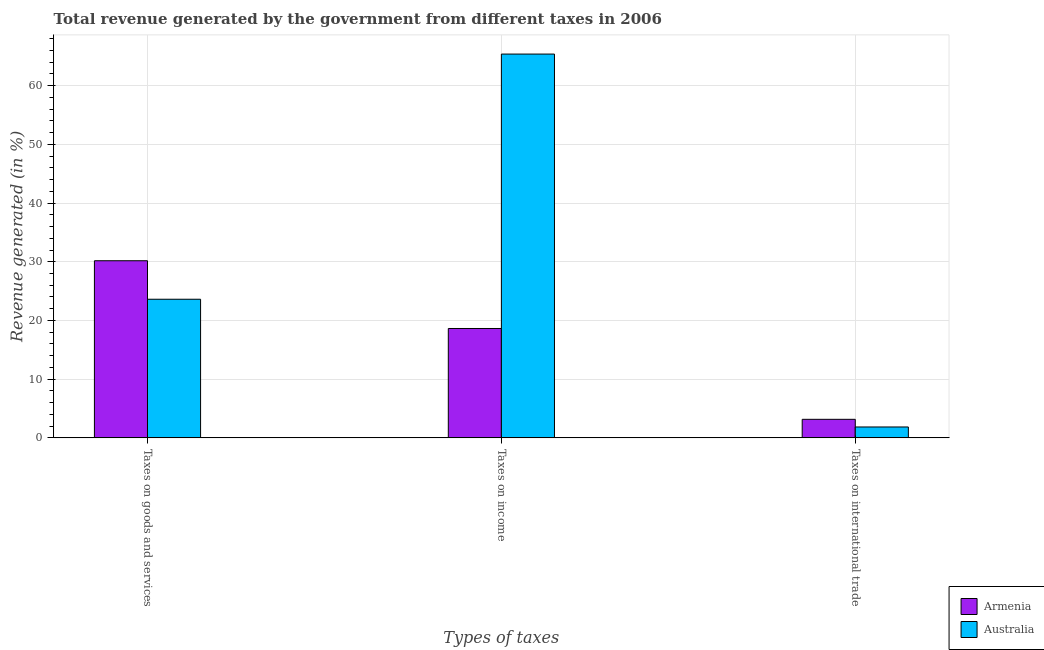How many different coloured bars are there?
Your response must be concise. 2. How many groups of bars are there?
Ensure brevity in your answer.  3. Are the number of bars per tick equal to the number of legend labels?
Ensure brevity in your answer.  Yes. Are the number of bars on each tick of the X-axis equal?
Your answer should be very brief. Yes. How many bars are there on the 2nd tick from the left?
Your response must be concise. 2. What is the label of the 3rd group of bars from the left?
Offer a very short reply. Taxes on international trade. What is the percentage of revenue generated by tax on international trade in Armenia?
Keep it short and to the point. 3.16. Across all countries, what is the maximum percentage of revenue generated by tax on international trade?
Give a very brief answer. 3.16. Across all countries, what is the minimum percentage of revenue generated by tax on international trade?
Offer a terse response. 1.86. In which country was the percentage of revenue generated by tax on international trade maximum?
Your answer should be compact. Armenia. In which country was the percentage of revenue generated by taxes on income minimum?
Your answer should be very brief. Armenia. What is the total percentage of revenue generated by taxes on income in the graph?
Give a very brief answer. 84.01. What is the difference between the percentage of revenue generated by taxes on income in Armenia and that in Australia?
Keep it short and to the point. -46.75. What is the difference between the percentage of revenue generated by tax on international trade in Australia and the percentage of revenue generated by taxes on goods and services in Armenia?
Your response must be concise. -28.31. What is the average percentage of revenue generated by taxes on income per country?
Your response must be concise. 42. What is the difference between the percentage of revenue generated by taxes on goods and services and percentage of revenue generated by tax on international trade in Armenia?
Offer a very short reply. 27.01. In how many countries, is the percentage of revenue generated by taxes on goods and services greater than 66 %?
Make the answer very short. 0. What is the ratio of the percentage of revenue generated by tax on international trade in Armenia to that in Australia?
Ensure brevity in your answer.  1.7. Is the percentage of revenue generated by taxes on income in Armenia less than that in Australia?
Ensure brevity in your answer.  Yes. Is the difference between the percentage of revenue generated by taxes on income in Armenia and Australia greater than the difference between the percentage of revenue generated by taxes on goods and services in Armenia and Australia?
Offer a very short reply. No. What is the difference between the highest and the second highest percentage of revenue generated by taxes on income?
Keep it short and to the point. 46.75. What is the difference between the highest and the lowest percentage of revenue generated by taxes on goods and services?
Your answer should be very brief. 6.56. In how many countries, is the percentage of revenue generated by tax on international trade greater than the average percentage of revenue generated by tax on international trade taken over all countries?
Your answer should be compact. 1. Is the sum of the percentage of revenue generated by taxes on income in Armenia and Australia greater than the maximum percentage of revenue generated by taxes on goods and services across all countries?
Keep it short and to the point. Yes. What does the 1st bar from the left in Taxes on income represents?
Provide a succinct answer. Armenia. What does the 1st bar from the right in Taxes on income represents?
Ensure brevity in your answer.  Australia. Is it the case that in every country, the sum of the percentage of revenue generated by taxes on goods and services and percentage of revenue generated by taxes on income is greater than the percentage of revenue generated by tax on international trade?
Your answer should be very brief. Yes. Are all the bars in the graph horizontal?
Give a very brief answer. No. Does the graph contain any zero values?
Offer a very short reply. No. What is the title of the graph?
Keep it short and to the point. Total revenue generated by the government from different taxes in 2006. Does "Northern Mariana Islands" appear as one of the legend labels in the graph?
Provide a succinct answer. No. What is the label or title of the X-axis?
Provide a succinct answer. Types of taxes. What is the label or title of the Y-axis?
Provide a short and direct response. Revenue generated (in %). What is the Revenue generated (in %) of Armenia in Taxes on goods and services?
Ensure brevity in your answer.  30.17. What is the Revenue generated (in %) in Australia in Taxes on goods and services?
Your answer should be very brief. 23.61. What is the Revenue generated (in %) of Armenia in Taxes on income?
Keep it short and to the point. 18.63. What is the Revenue generated (in %) in Australia in Taxes on income?
Provide a succinct answer. 65.38. What is the Revenue generated (in %) in Armenia in Taxes on international trade?
Provide a short and direct response. 3.16. What is the Revenue generated (in %) in Australia in Taxes on international trade?
Keep it short and to the point. 1.86. Across all Types of taxes, what is the maximum Revenue generated (in %) in Armenia?
Keep it short and to the point. 30.17. Across all Types of taxes, what is the maximum Revenue generated (in %) in Australia?
Your answer should be very brief. 65.38. Across all Types of taxes, what is the minimum Revenue generated (in %) in Armenia?
Your answer should be very brief. 3.16. Across all Types of taxes, what is the minimum Revenue generated (in %) in Australia?
Provide a succinct answer. 1.86. What is the total Revenue generated (in %) of Armenia in the graph?
Keep it short and to the point. 51.96. What is the total Revenue generated (in %) of Australia in the graph?
Offer a very short reply. 90.85. What is the difference between the Revenue generated (in %) of Armenia in Taxes on goods and services and that in Taxes on income?
Your answer should be compact. 11.54. What is the difference between the Revenue generated (in %) in Australia in Taxes on goods and services and that in Taxes on income?
Provide a short and direct response. -41.76. What is the difference between the Revenue generated (in %) in Armenia in Taxes on goods and services and that in Taxes on international trade?
Ensure brevity in your answer.  27.01. What is the difference between the Revenue generated (in %) of Australia in Taxes on goods and services and that in Taxes on international trade?
Your response must be concise. 21.76. What is the difference between the Revenue generated (in %) in Armenia in Taxes on income and that in Taxes on international trade?
Your response must be concise. 15.47. What is the difference between the Revenue generated (in %) of Australia in Taxes on income and that in Taxes on international trade?
Offer a very short reply. 63.52. What is the difference between the Revenue generated (in %) in Armenia in Taxes on goods and services and the Revenue generated (in %) in Australia in Taxes on income?
Offer a very short reply. -35.21. What is the difference between the Revenue generated (in %) in Armenia in Taxes on goods and services and the Revenue generated (in %) in Australia in Taxes on international trade?
Make the answer very short. 28.31. What is the difference between the Revenue generated (in %) of Armenia in Taxes on income and the Revenue generated (in %) of Australia in Taxes on international trade?
Ensure brevity in your answer.  16.77. What is the average Revenue generated (in %) in Armenia per Types of taxes?
Provide a short and direct response. 17.32. What is the average Revenue generated (in %) in Australia per Types of taxes?
Make the answer very short. 30.28. What is the difference between the Revenue generated (in %) in Armenia and Revenue generated (in %) in Australia in Taxes on goods and services?
Give a very brief answer. 6.56. What is the difference between the Revenue generated (in %) in Armenia and Revenue generated (in %) in Australia in Taxes on income?
Offer a very short reply. -46.75. What is the difference between the Revenue generated (in %) of Armenia and Revenue generated (in %) of Australia in Taxes on international trade?
Offer a very short reply. 1.3. What is the ratio of the Revenue generated (in %) in Armenia in Taxes on goods and services to that in Taxes on income?
Your answer should be compact. 1.62. What is the ratio of the Revenue generated (in %) of Australia in Taxes on goods and services to that in Taxes on income?
Offer a very short reply. 0.36. What is the ratio of the Revenue generated (in %) of Armenia in Taxes on goods and services to that in Taxes on international trade?
Your answer should be compact. 9.55. What is the ratio of the Revenue generated (in %) in Australia in Taxes on goods and services to that in Taxes on international trade?
Your answer should be very brief. 12.72. What is the ratio of the Revenue generated (in %) in Armenia in Taxes on income to that in Taxes on international trade?
Your answer should be very brief. 5.89. What is the ratio of the Revenue generated (in %) of Australia in Taxes on income to that in Taxes on international trade?
Your answer should be compact. 35.22. What is the difference between the highest and the second highest Revenue generated (in %) in Armenia?
Offer a very short reply. 11.54. What is the difference between the highest and the second highest Revenue generated (in %) of Australia?
Keep it short and to the point. 41.76. What is the difference between the highest and the lowest Revenue generated (in %) in Armenia?
Your answer should be compact. 27.01. What is the difference between the highest and the lowest Revenue generated (in %) of Australia?
Provide a short and direct response. 63.52. 